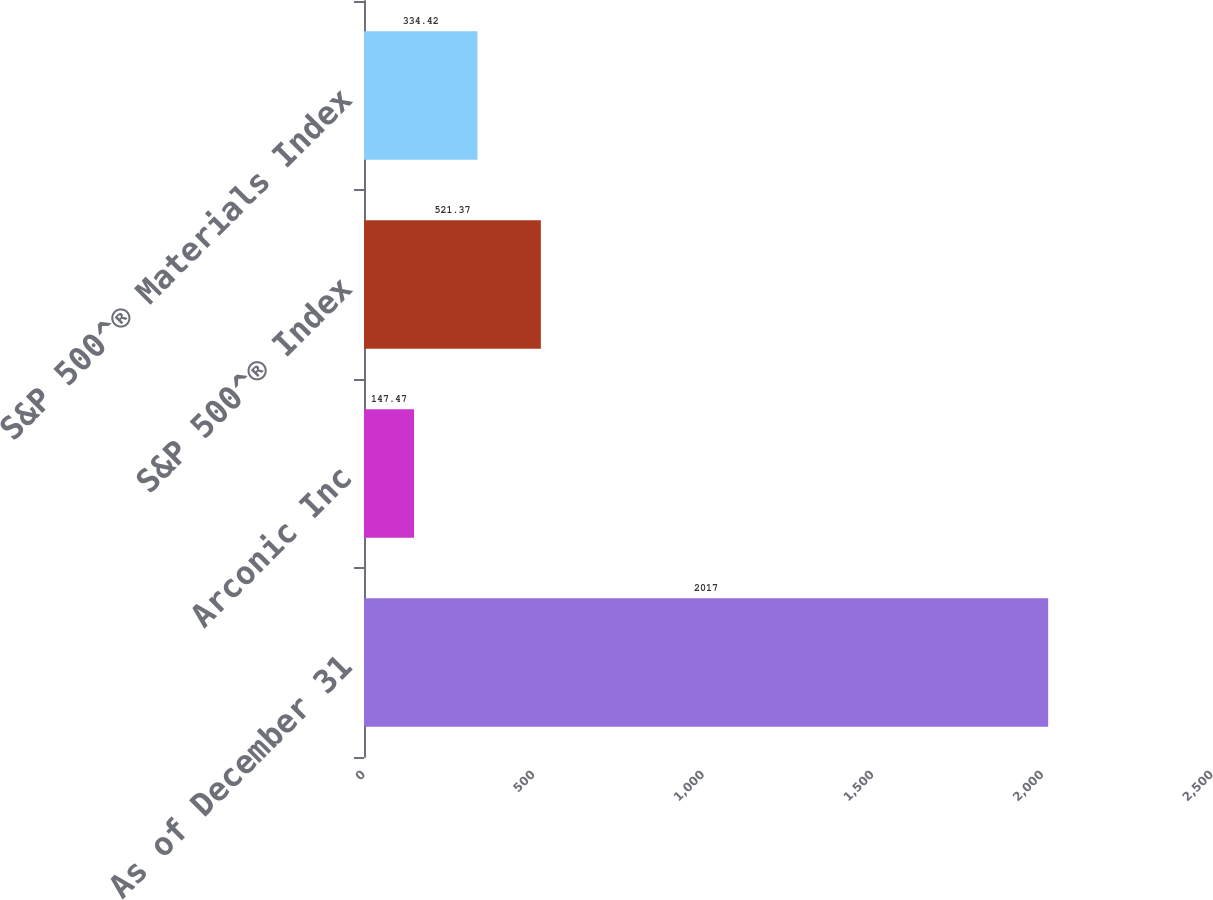<chart> <loc_0><loc_0><loc_500><loc_500><bar_chart><fcel>As of December 31<fcel>Arconic Inc<fcel>S&P 500^® Index<fcel>S&P 500^® Materials Index<nl><fcel>2017<fcel>147.47<fcel>521.37<fcel>334.42<nl></chart> 